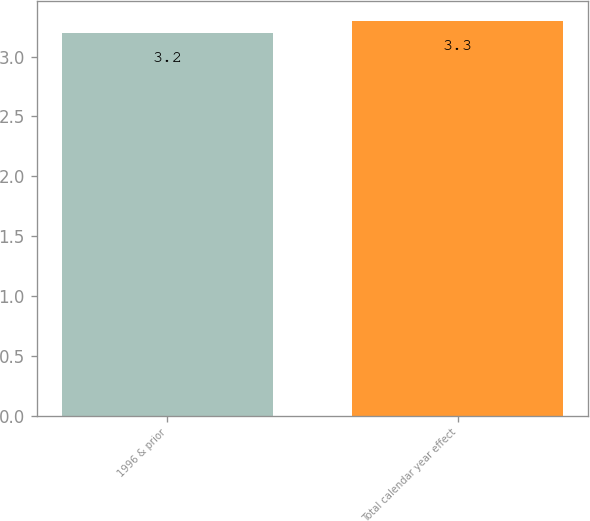<chart> <loc_0><loc_0><loc_500><loc_500><bar_chart><fcel>1996 & prior<fcel>Total calendar year effect<nl><fcel>3.2<fcel>3.3<nl></chart> 